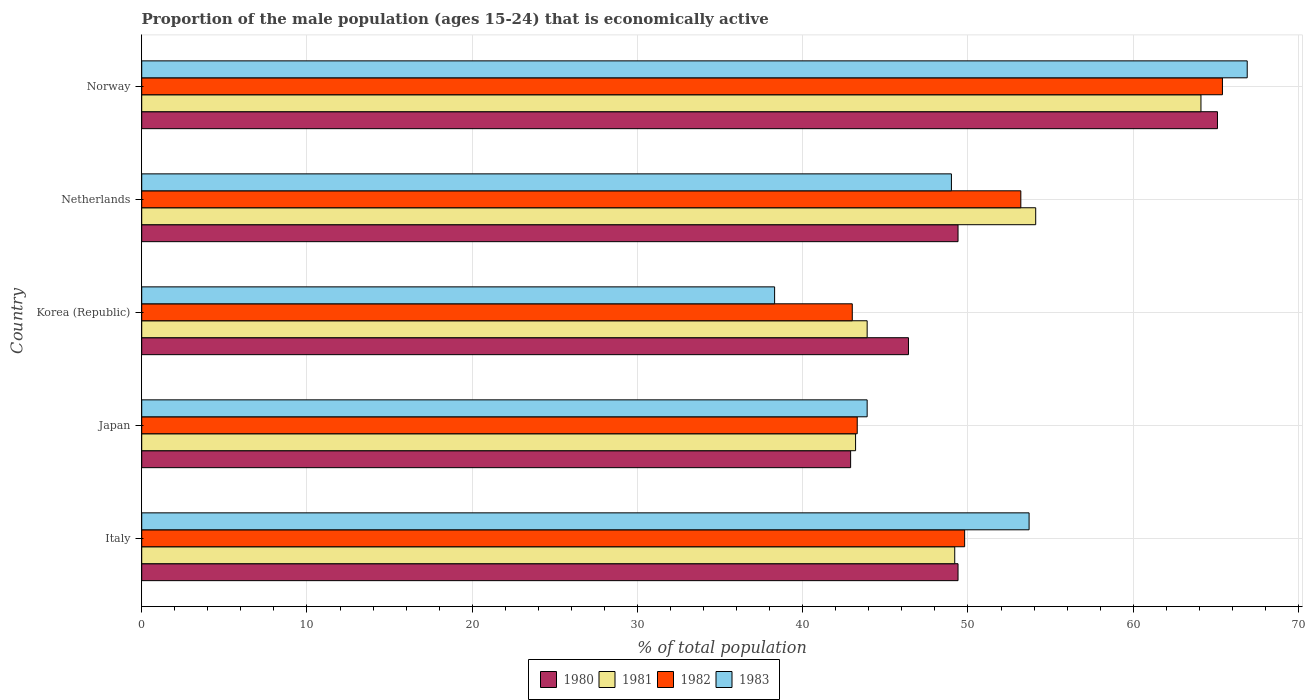How many groups of bars are there?
Your response must be concise. 5. How many bars are there on the 5th tick from the top?
Your answer should be very brief. 4. In how many cases, is the number of bars for a given country not equal to the number of legend labels?
Offer a very short reply. 0. What is the proportion of the male population that is economically active in 1980 in Norway?
Provide a succinct answer. 65.1. Across all countries, what is the maximum proportion of the male population that is economically active in 1982?
Your answer should be compact. 65.4. Across all countries, what is the minimum proportion of the male population that is economically active in 1980?
Keep it short and to the point. 42.9. What is the total proportion of the male population that is economically active in 1981 in the graph?
Your response must be concise. 254.5. What is the difference between the proportion of the male population that is economically active in 1981 in Netherlands and that in Norway?
Keep it short and to the point. -10. What is the difference between the proportion of the male population that is economically active in 1982 in Japan and the proportion of the male population that is economically active in 1980 in Netherlands?
Your response must be concise. -6.1. What is the average proportion of the male population that is economically active in 1982 per country?
Ensure brevity in your answer.  50.94. What is the difference between the proportion of the male population that is economically active in 1982 and proportion of the male population that is economically active in 1981 in Italy?
Provide a succinct answer. 0.6. In how many countries, is the proportion of the male population that is economically active in 1982 greater than 66 %?
Keep it short and to the point. 0. What is the ratio of the proportion of the male population that is economically active in 1980 in Italy to that in Japan?
Your response must be concise. 1.15. Is the proportion of the male population that is economically active in 1982 in Korea (Republic) less than that in Norway?
Offer a very short reply. Yes. Is the difference between the proportion of the male population that is economically active in 1982 in Italy and Norway greater than the difference between the proportion of the male population that is economically active in 1981 in Italy and Norway?
Give a very brief answer. No. What is the difference between the highest and the second highest proportion of the male population that is economically active in 1982?
Offer a terse response. 12.2. What is the difference between the highest and the lowest proportion of the male population that is economically active in 1983?
Provide a succinct answer. 28.6. Is the sum of the proportion of the male population that is economically active in 1982 in Italy and Netherlands greater than the maximum proportion of the male population that is economically active in 1983 across all countries?
Offer a terse response. Yes. What does the 2nd bar from the top in Japan represents?
Offer a very short reply. 1982. How many bars are there?
Provide a short and direct response. 20. How many countries are there in the graph?
Give a very brief answer. 5. What is the difference between two consecutive major ticks on the X-axis?
Provide a short and direct response. 10. Does the graph contain any zero values?
Make the answer very short. No. How many legend labels are there?
Provide a short and direct response. 4. What is the title of the graph?
Your response must be concise. Proportion of the male population (ages 15-24) that is economically active. Does "1977" appear as one of the legend labels in the graph?
Provide a succinct answer. No. What is the label or title of the X-axis?
Your answer should be very brief. % of total population. What is the label or title of the Y-axis?
Offer a very short reply. Country. What is the % of total population in 1980 in Italy?
Your response must be concise. 49.4. What is the % of total population in 1981 in Italy?
Make the answer very short. 49.2. What is the % of total population in 1982 in Italy?
Offer a terse response. 49.8. What is the % of total population of 1983 in Italy?
Ensure brevity in your answer.  53.7. What is the % of total population in 1980 in Japan?
Keep it short and to the point. 42.9. What is the % of total population of 1981 in Japan?
Your answer should be very brief. 43.2. What is the % of total population of 1982 in Japan?
Your response must be concise. 43.3. What is the % of total population in 1983 in Japan?
Offer a terse response. 43.9. What is the % of total population of 1980 in Korea (Republic)?
Offer a very short reply. 46.4. What is the % of total population in 1981 in Korea (Republic)?
Offer a very short reply. 43.9. What is the % of total population in 1982 in Korea (Republic)?
Make the answer very short. 43. What is the % of total population in 1983 in Korea (Republic)?
Offer a terse response. 38.3. What is the % of total population of 1980 in Netherlands?
Provide a short and direct response. 49.4. What is the % of total population in 1981 in Netherlands?
Keep it short and to the point. 54.1. What is the % of total population of 1982 in Netherlands?
Provide a succinct answer. 53.2. What is the % of total population of 1983 in Netherlands?
Provide a succinct answer. 49. What is the % of total population in 1980 in Norway?
Provide a short and direct response. 65.1. What is the % of total population of 1981 in Norway?
Ensure brevity in your answer.  64.1. What is the % of total population in 1982 in Norway?
Keep it short and to the point. 65.4. What is the % of total population in 1983 in Norway?
Keep it short and to the point. 66.9. Across all countries, what is the maximum % of total population in 1980?
Your response must be concise. 65.1. Across all countries, what is the maximum % of total population of 1981?
Your answer should be very brief. 64.1. Across all countries, what is the maximum % of total population of 1982?
Your response must be concise. 65.4. Across all countries, what is the maximum % of total population of 1983?
Offer a terse response. 66.9. Across all countries, what is the minimum % of total population of 1980?
Make the answer very short. 42.9. Across all countries, what is the minimum % of total population in 1981?
Give a very brief answer. 43.2. Across all countries, what is the minimum % of total population in 1983?
Make the answer very short. 38.3. What is the total % of total population of 1980 in the graph?
Offer a very short reply. 253.2. What is the total % of total population in 1981 in the graph?
Provide a succinct answer. 254.5. What is the total % of total population of 1982 in the graph?
Your answer should be compact. 254.7. What is the total % of total population in 1983 in the graph?
Make the answer very short. 251.8. What is the difference between the % of total population of 1980 in Italy and that in Japan?
Ensure brevity in your answer.  6.5. What is the difference between the % of total population in 1982 in Italy and that in Japan?
Make the answer very short. 6.5. What is the difference between the % of total population of 1980 in Italy and that in Korea (Republic)?
Your answer should be compact. 3. What is the difference between the % of total population in 1981 in Italy and that in Korea (Republic)?
Make the answer very short. 5.3. What is the difference between the % of total population in 1983 in Italy and that in Korea (Republic)?
Offer a terse response. 15.4. What is the difference between the % of total population of 1980 in Italy and that in Netherlands?
Your answer should be compact. 0. What is the difference between the % of total population of 1983 in Italy and that in Netherlands?
Your response must be concise. 4.7. What is the difference between the % of total population in 1980 in Italy and that in Norway?
Offer a very short reply. -15.7. What is the difference between the % of total population of 1981 in Italy and that in Norway?
Ensure brevity in your answer.  -14.9. What is the difference between the % of total population of 1982 in Italy and that in Norway?
Your answer should be very brief. -15.6. What is the difference between the % of total population in 1983 in Italy and that in Norway?
Offer a terse response. -13.2. What is the difference between the % of total population in 1981 in Japan and that in Korea (Republic)?
Offer a terse response. -0.7. What is the difference between the % of total population of 1982 in Japan and that in Netherlands?
Make the answer very short. -9.9. What is the difference between the % of total population of 1983 in Japan and that in Netherlands?
Your response must be concise. -5.1. What is the difference between the % of total population of 1980 in Japan and that in Norway?
Make the answer very short. -22.2. What is the difference between the % of total population in 1981 in Japan and that in Norway?
Your answer should be very brief. -20.9. What is the difference between the % of total population in 1982 in Japan and that in Norway?
Provide a succinct answer. -22.1. What is the difference between the % of total population in 1980 in Korea (Republic) and that in Netherlands?
Your response must be concise. -3. What is the difference between the % of total population in 1981 in Korea (Republic) and that in Netherlands?
Make the answer very short. -10.2. What is the difference between the % of total population of 1980 in Korea (Republic) and that in Norway?
Your response must be concise. -18.7. What is the difference between the % of total population in 1981 in Korea (Republic) and that in Norway?
Keep it short and to the point. -20.2. What is the difference between the % of total population of 1982 in Korea (Republic) and that in Norway?
Provide a succinct answer. -22.4. What is the difference between the % of total population in 1983 in Korea (Republic) and that in Norway?
Provide a short and direct response. -28.6. What is the difference between the % of total population in 1980 in Netherlands and that in Norway?
Give a very brief answer. -15.7. What is the difference between the % of total population of 1982 in Netherlands and that in Norway?
Your answer should be compact. -12.2. What is the difference between the % of total population of 1983 in Netherlands and that in Norway?
Provide a succinct answer. -17.9. What is the difference between the % of total population in 1980 in Italy and the % of total population in 1982 in Japan?
Make the answer very short. 6.1. What is the difference between the % of total population of 1980 in Italy and the % of total population of 1983 in Japan?
Provide a succinct answer. 5.5. What is the difference between the % of total population in 1981 in Italy and the % of total population in 1982 in Japan?
Provide a succinct answer. 5.9. What is the difference between the % of total population of 1982 in Italy and the % of total population of 1983 in Japan?
Your response must be concise. 5.9. What is the difference between the % of total population in 1980 in Italy and the % of total population in 1983 in Korea (Republic)?
Offer a terse response. 11.1. What is the difference between the % of total population in 1981 in Italy and the % of total population in 1982 in Korea (Republic)?
Offer a terse response. 6.2. What is the difference between the % of total population of 1981 in Italy and the % of total population of 1983 in Korea (Republic)?
Your answer should be compact. 10.9. What is the difference between the % of total population of 1982 in Italy and the % of total population of 1983 in Korea (Republic)?
Provide a succinct answer. 11.5. What is the difference between the % of total population in 1981 in Italy and the % of total population in 1983 in Netherlands?
Your answer should be very brief. 0.2. What is the difference between the % of total population in 1982 in Italy and the % of total population in 1983 in Netherlands?
Your answer should be very brief. 0.8. What is the difference between the % of total population in 1980 in Italy and the % of total population in 1981 in Norway?
Provide a short and direct response. -14.7. What is the difference between the % of total population in 1980 in Italy and the % of total population in 1982 in Norway?
Ensure brevity in your answer.  -16. What is the difference between the % of total population in 1980 in Italy and the % of total population in 1983 in Norway?
Offer a very short reply. -17.5. What is the difference between the % of total population of 1981 in Italy and the % of total population of 1982 in Norway?
Your answer should be compact. -16.2. What is the difference between the % of total population in 1981 in Italy and the % of total population in 1983 in Norway?
Offer a terse response. -17.7. What is the difference between the % of total population of 1982 in Italy and the % of total population of 1983 in Norway?
Give a very brief answer. -17.1. What is the difference between the % of total population of 1980 in Japan and the % of total population of 1981 in Korea (Republic)?
Your answer should be compact. -1. What is the difference between the % of total population of 1980 in Japan and the % of total population of 1982 in Korea (Republic)?
Your answer should be compact. -0.1. What is the difference between the % of total population in 1980 in Japan and the % of total population in 1983 in Korea (Republic)?
Provide a short and direct response. 4.6. What is the difference between the % of total population in 1981 in Japan and the % of total population in 1982 in Korea (Republic)?
Offer a very short reply. 0.2. What is the difference between the % of total population in 1981 in Japan and the % of total population in 1983 in Korea (Republic)?
Your answer should be compact. 4.9. What is the difference between the % of total population in 1980 in Japan and the % of total population in 1983 in Netherlands?
Your response must be concise. -6.1. What is the difference between the % of total population of 1982 in Japan and the % of total population of 1983 in Netherlands?
Your answer should be very brief. -5.7. What is the difference between the % of total population of 1980 in Japan and the % of total population of 1981 in Norway?
Provide a succinct answer. -21.2. What is the difference between the % of total population of 1980 in Japan and the % of total population of 1982 in Norway?
Offer a terse response. -22.5. What is the difference between the % of total population in 1981 in Japan and the % of total population in 1982 in Norway?
Provide a short and direct response. -22.2. What is the difference between the % of total population in 1981 in Japan and the % of total population in 1983 in Norway?
Provide a short and direct response. -23.7. What is the difference between the % of total population of 1982 in Japan and the % of total population of 1983 in Norway?
Give a very brief answer. -23.6. What is the difference between the % of total population of 1981 in Korea (Republic) and the % of total population of 1982 in Netherlands?
Your response must be concise. -9.3. What is the difference between the % of total population in 1981 in Korea (Republic) and the % of total population in 1983 in Netherlands?
Provide a short and direct response. -5.1. What is the difference between the % of total population of 1980 in Korea (Republic) and the % of total population of 1981 in Norway?
Provide a succinct answer. -17.7. What is the difference between the % of total population in 1980 in Korea (Republic) and the % of total population in 1983 in Norway?
Provide a short and direct response. -20.5. What is the difference between the % of total population of 1981 in Korea (Republic) and the % of total population of 1982 in Norway?
Provide a succinct answer. -21.5. What is the difference between the % of total population of 1982 in Korea (Republic) and the % of total population of 1983 in Norway?
Give a very brief answer. -23.9. What is the difference between the % of total population of 1980 in Netherlands and the % of total population of 1981 in Norway?
Offer a terse response. -14.7. What is the difference between the % of total population of 1980 in Netherlands and the % of total population of 1983 in Norway?
Offer a terse response. -17.5. What is the difference between the % of total population of 1981 in Netherlands and the % of total population of 1982 in Norway?
Give a very brief answer. -11.3. What is the difference between the % of total population of 1982 in Netherlands and the % of total population of 1983 in Norway?
Provide a succinct answer. -13.7. What is the average % of total population in 1980 per country?
Ensure brevity in your answer.  50.64. What is the average % of total population of 1981 per country?
Offer a very short reply. 50.9. What is the average % of total population of 1982 per country?
Ensure brevity in your answer.  50.94. What is the average % of total population of 1983 per country?
Keep it short and to the point. 50.36. What is the difference between the % of total population in 1980 and % of total population in 1982 in Italy?
Keep it short and to the point. -0.4. What is the difference between the % of total population of 1980 and % of total population of 1983 in Italy?
Offer a terse response. -4.3. What is the difference between the % of total population of 1981 and % of total population of 1983 in Italy?
Offer a terse response. -4.5. What is the difference between the % of total population of 1980 and % of total population of 1983 in Japan?
Ensure brevity in your answer.  -1. What is the difference between the % of total population in 1981 and % of total population in 1982 in Japan?
Keep it short and to the point. -0.1. What is the difference between the % of total population in 1981 and % of total population in 1983 in Japan?
Make the answer very short. -0.7. What is the difference between the % of total population in 1982 and % of total population in 1983 in Japan?
Your response must be concise. -0.6. What is the difference between the % of total population in 1981 and % of total population in 1982 in Korea (Republic)?
Provide a succinct answer. 0.9. What is the difference between the % of total population of 1981 and % of total population of 1983 in Korea (Republic)?
Your answer should be compact. 5.6. What is the difference between the % of total population in 1982 and % of total population in 1983 in Korea (Republic)?
Offer a very short reply. 4.7. What is the difference between the % of total population of 1980 and % of total population of 1982 in Netherlands?
Give a very brief answer. -3.8. What is the difference between the % of total population of 1981 and % of total population of 1982 in Netherlands?
Provide a succinct answer. 0.9. What is the difference between the % of total population in 1981 and % of total population in 1983 in Netherlands?
Offer a very short reply. 5.1. What is the difference between the % of total population in 1980 and % of total population in 1982 in Norway?
Offer a very short reply. -0.3. What is the difference between the % of total population of 1980 and % of total population of 1983 in Norway?
Provide a succinct answer. -1.8. What is the difference between the % of total population of 1981 and % of total population of 1982 in Norway?
Offer a terse response. -1.3. What is the difference between the % of total population in 1981 and % of total population in 1983 in Norway?
Your answer should be compact. -2.8. What is the difference between the % of total population in 1982 and % of total population in 1983 in Norway?
Your response must be concise. -1.5. What is the ratio of the % of total population of 1980 in Italy to that in Japan?
Offer a terse response. 1.15. What is the ratio of the % of total population of 1981 in Italy to that in Japan?
Give a very brief answer. 1.14. What is the ratio of the % of total population of 1982 in Italy to that in Japan?
Provide a succinct answer. 1.15. What is the ratio of the % of total population in 1983 in Italy to that in Japan?
Ensure brevity in your answer.  1.22. What is the ratio of the % of total population of 1980 in Italy to that in Korea (Republic)?
Offer a very short reply. 1.06. What is the ratio of the % of total population in 1981 in Italy to that in Korea (Republic)?
Make the answer very short. 1.12. What is the ratio of the % of total population of 1982 in Italy to that in Korea (Republic)?
Keep it short and to the point. 1.16. What is the ratio of the % of total population in 1983 in Italy to that in Korea (Republic)?
Make the answer very short. 1.4. What is the ratio of the % of total population in 1981 in Italy to that in Netherlands?
Make the answer very short. 0.91. What is the ratio of the % of total population in 1982 in Italy to that in Netherlands?
Your answer should be very brief. 0.94. What is the ratio of the % of total population of 1983 in Italy to that in Netherlands?
Your response must be concise. 1.1. What is the ratio of the % of total population of 1980 in Italy to that in Norway?
Offer a terse response. 0.76. What is the ratio of the % of total population in 1981 in Italy to that in Norway?
Provide a succinct answer. 0.77. What is the ratio of the % of total population in 1982 in Italy to that in Norway?
Your answer should be very brief. 0.76. What is the ratio of the % of total population in 1983 in Italy to that in Norway?
Your answer should be compact. 0.8. What is the ratio of the % of total population of 1980 in Japan to that in Korea (Republic)?
Ensure brevity in your answer.  0.92. What is the ratio of the % of total population of 1981 in Japan to that in Korea (Republic)?
Keep it short and to the point. 0.98. What is the ratio of the % of total population in 1983 in Japan to that in Korea (Republic)?
Provide a succinct answer. 1.15. What is the ratio of the % of total population of 1980 in Japan to that in Netherlands?
Make the answer very short. 0.87. What is the ratio of the % of total population of 1981 in Japan to that in Netherlands?
Your answer should be compact. 0.8. What is the ratio of the % of total population of 1982 in Japan to that in Netherlands?
Ensure brevity in your answer.  0.81. What is the ratio of the % of total population of 1983 in Japan to that in Netherlands?
Ensure brevity in your answer.  0.9. What is the ratio of the % of total population of 1980 in Japan to that in Norway?
Ensure brevity in your answer.  0.66. What is the ratio of the % of total population in 1981 in Japan to that in Norway?
Ensure brevity in your answer.  0.67. What is the ratio of the % of total population in 1982 in Japan to that in Norway?
Your answer should be very brief. 0.66. What is the ratio of the % of total population in 1983 in Japan to that in Norway?
Your response must be concise. 0.66. What is the ratio of the % of total population of 1980 in Korea (Republic) to that in Netherlands?
Offer a terse response. 0.94. What is the ratio of the % of total population of 1981 in Korea (Republic) to that in Netherlands?
Keep it short and to the point. 0.81. What is the ratio of the % of total population in 1982 in Korea (Republic) to that in Netherlands?
Make the answer very short. 0.81. What is the ratio of the % of total population in 1983 in Korea (Republic) to that in Netherlands?
Provide a short and direct response. 0.78. What is the ratio of the % of total population of 1980 in Korea (Republic) to that in Norway?
Give a very brief answer. 0.71. What is the ratio of the % of total population in 1981 in Korea (Republic) to that in Norway?
Offer a very short reply. 0.68. What is the ratio of the % of total population in 1982 in Korea (Republic) to that in Norway?
Offer a very short reply. 0.66. What is the ratio of the % of total population in 1983 in Korea (Republic) to that in Norway?
Your response must be concise. 0.57. What is the ratio of the % of total population of 1980 in Netherlands to that in Norway?
Ensure brevity in your answer.  0.76. What is the ratio of the % of total population in 1981 in Netherlands to that in Norway?
Ensure brevity in your answer.  0.84. What is the ratio of the % of total population of 1982 in Netherlands to that in Norway?
Your answer should be compact. 0.81. What is the ratio of the % of total population of 1983 in Netherlands to that in Norway?
Make the answer very short. 0.73. What is the difference between the highest and the second highest % of total population in 1981?
Your answer should be very brief. 10. What is the difference between the highest and the second highest % of total population in 1982?
Give a very brief answer. 12.2. What is the difference between the highest and the second highest % of total population in 1983?
Your response must be concise. 13.2. What is the difference between the highest and the lowest % of total population of 1981?
Keep it short and to the point. 20.9. What is the difference between the highest and the lowest % of total population in 1982?
Ensure brevity in your answer.  22.4. What is the difference between the highest and the lowest % of total population in 1983?
Keep it short and to the point. 28.6. 